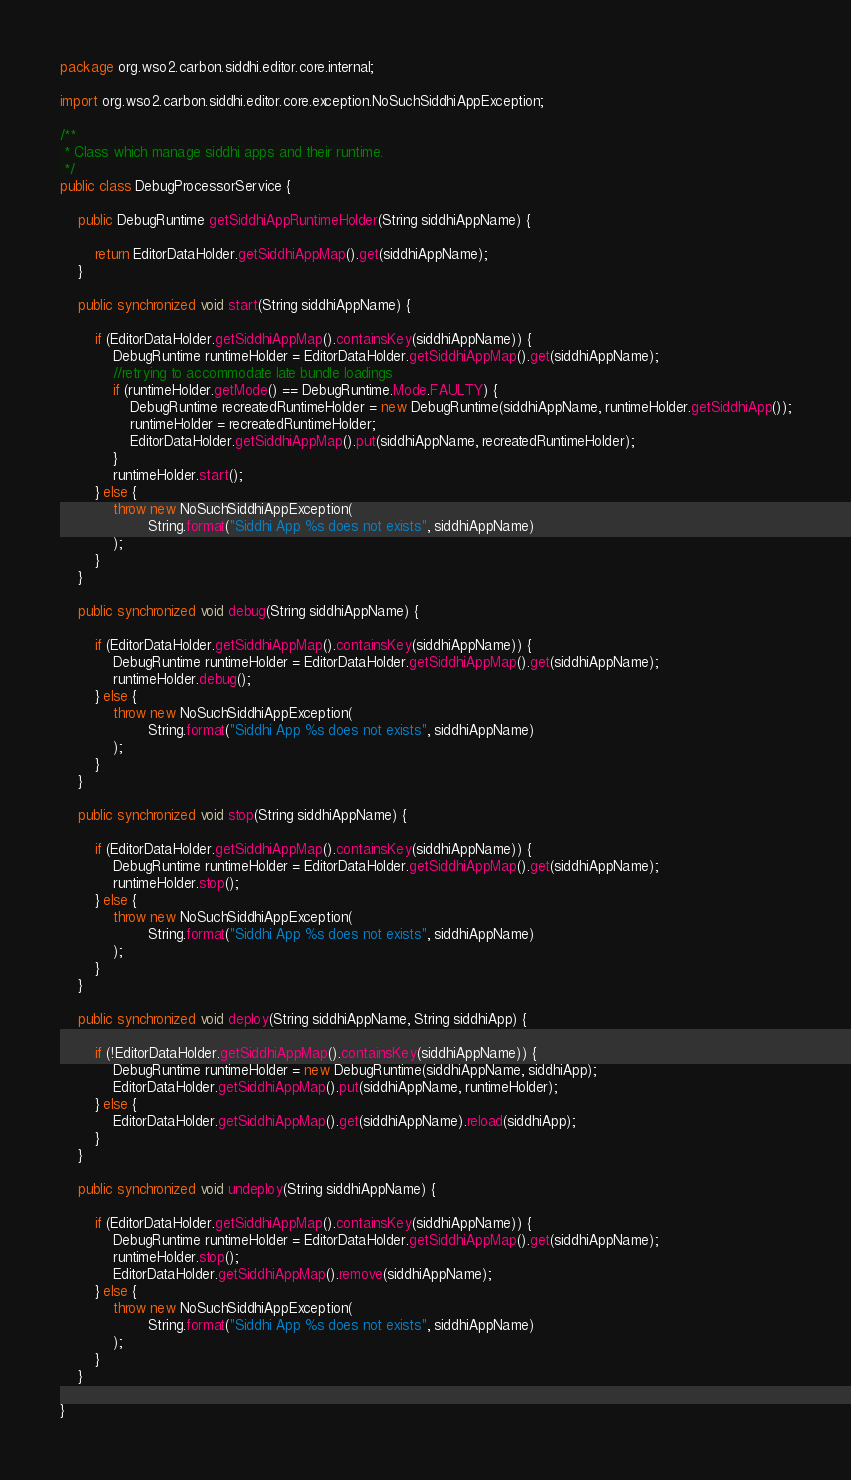Convert code to text. <code><loc_0><loc_0><loc_500><loc_500><_Java_>package org.wso2.carbon.siddhi.editor.core.internal;

import org.wso2.carbon.siddhi.editor.core.exception.NoSuchSiddhiAppException;

/**
 * Class which manage siddhi apps and their runtime.
 */
public class DebugProcessorService {

    public DebugRuntime getSiddhiAppRuntimeHolder(String siddhiAppName) {

        return EditorDataHolder.getSiddhiAppMap().get(siddhiAppName);
    }

    public synchronized void start(String siddhiAppName) {

        if (EditorDataHolder.getSiddhiAppMap().containsKey(siddhiAppName)) {
            DebugRuntime runtimeHolder = EditorDataHolder.getSiddhiAppMap().get(siddhiAppName);
            //retrying to accommodate late bundle loadings
            if (runtimeHolder.getMode() == DebugRuntime.Mode.FAULTY) {
                DebugRuntime recreatedRuntimeHolder = new DebugRuntime(siddhiAppName, runtimeHolder.getSiddhiApp());
                runtimeHolder = recreatedRuntimeHolder;
                EditorDataHolder.getSiddhiAppMap().put(siddhiAppName, recreatedRuntimeHolder);
            }
            runtimeHolder.start();
        } else {
            throw new NoSuchSiddhiAppException(
                    String.format("Siddhi App %s does not exists", siddhiAppName)
            );
        }
    }

    public synchronized void debug(String siddhiAppName) {

        if (EditorDataHolder.getSiddhiAppMap().containsKey(siddhiAppName)) {
            DebugRuntime runtimeHolder = EditorDataHolder.getSiddhiAppMap().get(siddhiAppName);
            runtimeHolder.debug();
        } else {
            throw new NoSuchSiddhiAppException(
                    String.format("Siddhi App %s does not exists", siddhiAppName)
            );
        }
    }

    public synchronized void stop(String siddhiAppName) {

        if (EditorDataHolder.getSiddhiAppMap().containsKey(siddhiAppName)) {
            DebugRuntime runtimeHolder = EditorDataHolder.getSiddhiAppMap().get(siddhiAppName);
            runtimeHolder.stop();
        } else {
            throw new NoSuchSiddhiAppException(
                    String.format("Siddhi App %s does not exists", siddhiAppName)
            );
        }
    }

    public synchronized void deploy(String siddhiAppName, String siddhiApp) {

        if (!EditorDataHolder.getSiddhiAppMap().containsKey(siddhiAppName)) {
            DebugRuntime runtimeHolder = new DebugRuntime(siddhiAppName, siddhiApp);
            EditorDataHolder.getSiddhiAppMap().put(siddhiAppName, runtimeHolder);
        } else {
            EditorDataHolder.getSiddhiAppMap().get(siddhiAppName).reload(siddhiApp);
        }
    }

    public synchronized void undeploy(String siddhiAppName) {

        if (EditorDataHolder.getSiddhiAppMap().containsKey(siddhiAppName)) {
            DebugRuntime runtimeHolder = EditorDataHolder.getSiddhiAppMap().get(siddhiAppName);
            runtimeHolder.stop();
            EditorDataHolder.getSiddhiAppMap().remove(siddhiAppName);
        } else {
            throw new NoSuchSiddhiAppException(
                    String.format("Siddhi App %s does not exists", siddhiAppName)
            );
        }
    }

}
</code> 